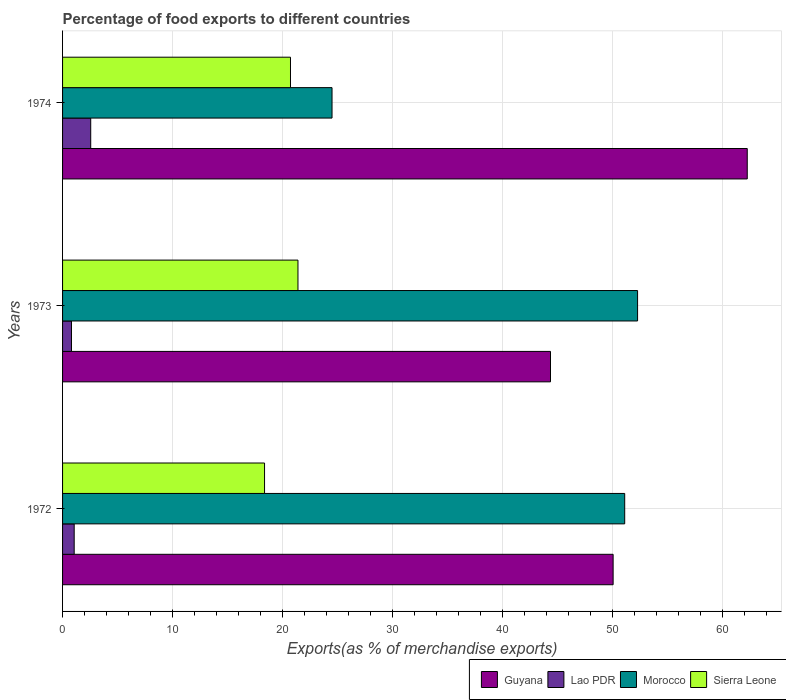How many different coloured bars are there?
Provide a short and direct response. 4. Are the number of bars per tick equal to the number of legend labels?
Provide a short and direct response. Yes. Are the number of bars on each tick of the Y-axis equal?
Provide a succinct answer. Yes. What is the label of the 2nd group of bars from the top?
Provide a short and direct response. 1973. In how many cases, is the number of bars for a given year not equal to the number of legend labels?
Keep it short and to the point. 0. What is the percentage of exports to different countries in Lao PDR in 1973?
Keep it short and to the point. 0.81. Across all years, what is the maximum percentage of exports to different countries in Lao PDR?
Your response must be concise. 2.56. Across all years, what is the minimum percentage of exports to different countries in Lao PDR?
Provide a succinct answer. 0.81. In which year was the percentage of exports to different countries in Lao PDR maximum?
Your answer should be very brief. 1974. In which year was the percentage of exports to different countries in Morocco minimum?
Provide a succinct answer. 1974. What is the total percentage of exports to different countries in Guyana in the graph?
Ensure brevity in your answer.  156.74. What is the difference between the percentage of exports to different countries in Lao PDR in 1973 and that in 1974?
Provide a succinct answer. -1.75. What is the difference between the percentage of exports to different countries in Lao PDR in 1973 and the percentage of exports to different countries in Guyana in 1972?
Keep it short and to the point. -49.27. What is the average percentage of exports to different countries in Guyana per year?
Provide a short and direct response. 52.25. In the year 1972, what is the difference between the percentage of exports to different countries in Sierra Leone and percentage of exports to different countries in Morocco?
Your answer should be very brief. -32.76. What is the ratio of the percentage of exports to different countries in Guyana in 1973 to that in 1974?
Ensure brevity in your answer.  0.71. Is the percentage of exports to different countries in Sierra Leone in 1972 less than that in 1973?
Offer a very short reply. Yes. What is the difference between the highest and the second highest percentage of exports to different countries in Lao PDR?
Your answer should be very brief. 1.5. What is the difference between the highest and the lowest percentage of exports to different countries in Morocco?
Give a very brief answer. 27.79. Is it the case that in every year, the sum of the percentage of exports to different countries in Lao PDR and percentage of exports to different countries in Guyana is greater than the sum of percentage of exports to different countries in Sierra Leone and percentage of exports to different countries in Morocco?
Make the answer very short. No. What does the 2nd bar from the top in 1972 represents?
Provide a short and direct response. Morocco. What does the 1st bar from the bottom in 1974 represents?
Provide a succinct answer. Guyana. Is it the case that in every year, the sum of the percentage of exports to different countries in Guyana and percentage of exports to different countries in Morocco is greater than the percentage of exports to different countries in Sierra Leone?
Your response must be concise. Yes. How many bars are there?
Your response must be concise. 12. Are all the bars in the graph horizontal?
Provide a succinct answer. Yes. Does the graph contain any zero values?
Your answer should be very brief. No. Does the graph contain grids?
Give a very brief answer. Yes. Where does the legend appear in the graph?
Your answer should be very brief. Bottom right. What is the title of the graph?
Your response must be concise. Percentage of food exports to different countries. Does "Slovenia" appear as one of the legend labels in the graph?
Your answer should be very brief. No. What is the label or title of the X-axis?
Your response must be concise. Exports(as % of merchandise exports). What is the Exports(as % of merchandise exports) of Guyana in 1972?
Offer a terse response. 50.08. What is the Exports(as % of merchandise exports) in Lao PDR in 1972?
Offer a very short reply. 1.06. What is the Exports(as % of merchandise exports) in Morocco in 1972?
Your response must be concise. 51.13. What is the Exports(as % of merchandise exports) of Sierra Leone in 1972?
Your answer should be compact. 18.37. What is the Exports(as % of merchandise exports) of Guyana in 1973?
Give a very brief answer. 44.38. What is the Exports(as % of merchandise exports) of Lao PDR in 1973?
Offer a very short reply. 0.81. What is the Exports(as % of merchandise exports) in Morocco in 1973?
Your response must be concise. 52.3. What is the Exports(as % of merchandise exports) of Sierra Leone in 1973?
Offer a very short reply. 21.41. What is the Exports(as % of merchandise exports) of Guyana in 1974?
Make the answer very short. 62.28. What is the Exports(as % of merchandise exports) in Lao PDR in 1974?
Offer a terse response. 2.56. What is the Exports(as % of merchandise exports) in Morocco in 1974?
Offer a very short reply. 24.51. What is the Exports(as % of merchandise exports) in Sierra Leone in 1974?
Your answer should be compact. 20.73. Across all years, what is the maximum Exports(as % of merchandise exports) of Guyana?
Keep it short and to the point. 62.28. Across all years, what is the maximum Exports(as % of merchandise exports) in Lao PDR?
Provide a succinct answer. 2.56. Across all years, what is the maximum Exports(as % of merchandise exports) of Morocco?
Make the answer very short. 52.3. Across all years, what is the maximum Exports(as % of merchandise exports) of Sierra Leone?
Your response must be concise. 21.41. Across all years, what is the minimum Exports(as % of merchandise exports) of Guyana?
Your answer should be compact. 44.38. Across all years, what is the minimum Exports(as % of merchandise exports) of Lao PDR?
Ensure brevity in your answer.  0.81. Across all years, what is the minimum Exports(as % of merchandise exports) in Morocco?
Make the answer very short. 24.51. Across all years, what is the minimum Exports(as % of merchandise exports) of Sierra Leone?
Provide a succinct answer. 18.37. What is the total Exports(as % of merchandise exports) in Guyana in the graph?
Provide a succinct answer. 156.74. What is the total Exports(as % of merchandise exports) of Lao PDR in the graph?
Make the answer very short. 4.43. What is the total Exports(as % of merchandise exports) in Morocco in the graph?
Provide a short and direct response. 127.94. What is the total Exports(as % of merchandise exports) in Sierra Leone in the graph?
Provide a succinct answer. 60.51. What is the difference between the Exports(as % of merchandise exports) in Guyana in 1972 and that in 1973?
Provide a succinct answer. 5.7. What is the difference between the Exports(as % of merchandise exports) in Lao PDR in 1972 and that in 1973?
Provide a succinct answer. 0.25. What is the difference between the Exports(as % of merchandise exports) of Morocco in 1972 and that in 1973?
Offer a terse response. -1.17. What is the difference between the Exports(as % of merchandise exports) of Sierra Leone in 1972 and that in 1973?
Your response must be concise. -3.04. What is the difference between the Exports(as % of merchandise exports) in Guyana in 1972 and that in 1974?
Make the answer very short. -12.2. What is the difference between the Exports(as % of merchandise exports) of Lao PDR in 1972 and that in 1974?
Keep it short and to the point. -1.5. What is the difference between the Exports(as % of merchandise exports) in Morocco in 1972 and that in 1974?
Make the answer very short. 26.62. What is the difference between the Exports(as % of merchandise exports) in Sierra Leone in 1972 and that in 1974?
Ensure brevity in your answer.  -2.36. What is the difference between the Exports(as % of merchandise exports) of Guyana in 1973 and that in 1974?
Make the answer very short. -17.9. What is the difference between the Exports(as % of merchandise exports) of Lao PDR in 1973 and that in 1974?
Give a very brief answer. -1.75. What is the difference between the Exports(as % of merchandise exports) in Morocco in 1973 and that in 1974?
Ensure brevity in your answer.  27.79. What is the difference between the Exports(as % of merchandise exports) of Sierra Leone in 1973 and that in 1974?
Offer a very short reply. 0.68. What is the difference between the Exports(as % of merchandise exports) of Guyana in 1972 and the Exports(as % of merchandise exports) of Lao PDR in 1973?
Provide a succinct answer. 49.27. What is the difference between the Exports(as % of merchandise exports) of Guyana in 1972 and the Exports(as % of merchandise exports) of Morocco in 1973?
Your answer should be compact. -2.22. What is the difference between the Exports(as % of merchandise exports) in Guyana in 1972 and the Exports(as % of merchandise exports) in Sierra Leone in 1973?
Provide a succinct answer. 28.67. What is the difference between the Exports(as % of merchandise exports) of Lao PDR in 1972 and the Exports(as % of merchandise exports) of Morocco in 1973?
Your answer should be compact. -51.24. What is the difference between the Exports(as % of merchandise exports) in Lao PDR in 1972 and the Exports(as % of merchandise exports) in Sierra Leone in 1973?
Your answer should be very brief. -20.35. What is the difference between the Exports(as % of merchandise exports) in Morocco in 1972 and the Exports(as % of merchandise exports) in Sierra Leone in 1973?
Offer a terse response. 29.72. What is the difference between the Exports(as % of merchandise exports) of Guyana in 1972 and the Exports(as % of merchandise exports) of Lao PDR in 1974?
Your response must be concise. 47.52. What is the difference between the Exports(as % of merchandise exports) of Guyana in 1972 and the Exports(as % of merchandise exports) of Morocco in 1974?
Provide a succinct answer. 25.57. What is the difference between the Exports(as % of merchandise exports) in Guyana in 1972 and the Exports(as % of merchandise exports) in Sierra Leone in 1974?
Ensure brevity in your answer.  29.35. What is the difference between the Exports(as % of merchandise exports) of Lao PDR in 1972 and the Exports(as % of merchandise exports) of Morocco in 1974?
Provide a succinct answer. -23.45. What is the difference between the Exports(as % of merchandise exports) of Lao PDR in 1972 and the Exports(as % of merchandise exports) of Sierra Leone in 1974?
Provide a succinct answer. -19.67. What is the difference between the Exports(as % of merchandise exports) in Morocco in 1972 and the Exports(as % of merchandise exports) in Sierra Leone in 1974?
Provide a short and direct response. 30.4. What is the difference between the Exports(as % of merchandise exports) in Guyana in 1973 and the Exports(as % of merchandise exports) in Lao PDR in 1974?
Ensure brevity in your answer.  41.82. What is the difference between the Exports(as % of merchandise exports) of Guyana in 1973 and the Exports(as % of merchandise exports) of Morocco in 1974?
Your answer should be compact. 19.87. What is the difference between the Exports(as % of merchandise exports) in Guyana in 1973 and the Exports(as % of merchandise exports) in Sierra Leone in 1974?
Ensure brevity in your answer.  23.65. What is the difference between the Exports(as % of merchandise exports) of Lao PDR in 1973 and the Exports(as % of merchandise exports) of Morocco in 1974?
Your answer should be compact. -23.7. What is the difference between the Exports(as % of merchandise exports) of Lao PDR in 1973 and the Exports(as % of merchandise exports) of Sierra Leone in 1974?
Offer a terse response. -19.92. What is the difference between the Exports(as % of merchandise exports) of Morocco in 1973 and the Exports(as % of merchandise exports) of Sierra Leone in 1974?
Offer a very short reply. 31.57. What is the average Exports(as % of merchandise exports) of Guyana per year?
Your answer should be very brief. 52.25. What is the average Exports(as % of merchandise exports) in Lao PDR per year?
Provide a succinct answer. 1.48. What is the average Exports(as % of merchandise exports) in Morocco per year?
Provide a succinct answer. 42.65. What is the average Exports(as % of merchandise exports) of Sierra Leone per year?
Keep it short and to the point. 20.17. In the year 1972, what is the difference between the Exports(as % of merchandise exports) in Guyana and Exports(as % of merchandise exports) in Lao PDR?
Make the answer very short. 49.02. In the year 1972, what is the difference between the Exports(as % of merchandise exports) in Guyana and Exports(as % of merchandise exports) in Morocco?
Offer a very short reply. -1.05. In the year 1972, what is the difference between the Exports(as % of merchandise exports) in Guyana and Exports(as % of merchandise exports) in Sierra Leone?
Give a very brief answer. 31.71. In the year 1972, what is the difference between the Exports(as % of merchandise exports) in Lao PDR and Exports(as % of merchandise exports) in Morocco?
Ensure brevity in your answer.  -50.07. In the year 1972, what is the difference between the Exports(as % of merchandise exports) in Lao PDR and Exports(as % of merchandise exports) in Sierra Leone?
Offer a terse response. -17.31. In the year 1972, what is the difference between the Exports(as % of merchandise exports) in Morocco and Exports(as % of merchandise exports) in Sierra Leone?
Your answer should be very brief. 32.76. In the year 1973, what is the difference between the Exports(as % of merchandise exports) in Guyana and Exports(as % of merchandise exports) in Lao PDR?
Offer a terse response. 43.57. In the year 1973, what is the difference between the Exports(as % of merchandise exports) of Guyana and Exports(as % of merchandise exports) of Morocco?
Make the answer very short. -7.92. In the year 1973, what is the difference between the Exports(as % of merchandise exports) of Guyana and Exports(as % of merchandise exports) of Sierra Leone?
Ensure brevity in your answer.  22.97. In the year 1973, what is the difference between the Exports(as % of merchandise exports) in Lao PDR and Exports(as % of merchandise exports) in Morocco?
Keep it short and to the point. -51.49. In the year 1973, what is the difference between the Exports(as % of merchandise exports) in Lao PDR and Exports(as % of merchandise exports) in Sierra Leone?
Make the answer very short. -20.6. In the year 1973, what is the difference between the Exports(as % of merchandise exports) of Morocco and Exports(as % of merchandise exports) of Sierra Leone?
Your response must be concise. 30.89. In the year 1974, what is the difference between the Exports(as % of merchandise exports) in Guyana and Exports(as % of merchandise exports) in Lao PDR?
Provide a short and direct response. 59.72. In the year 1974, what is the difference between the Exports(as % of merchandise exports) of Guyana and Exports(as % of merchandise exports) of Morocco?
Make the answer very short. 37.77. In the year 1974, what is the difference between the Exports(as % of merchandise exports) of Guyana and Exports(as % of merchandise exports) of Sierra Leone?
Ensure brevity in your answer.  41.55. In the year 1974, what is the difference between the Exports(as % of merchandise exports) in Lao PDR and Exports(as % of merchandise exports) in Morocco?
Keep it short and to the point. -21.95. In the year 1974, what is the difference between the Exports(as % of merchandise exports) of Lao PDR and Exports(as % of merchandise exports) of Sierra Leone?
Offer a very short reply. -18.17. In the year 1974, what is the difference between the Exports(as % of merchandise exports) of Morocco and Exports(as % of merchandise exports) of Sierra Leone?
Provide a short and direct response. 3.78. What is the ratio of the Exports(as % of merchandise exports) of Guyana in 1972 to that in 1973?
Offer a very short reply. 1.13. What is the ratio of the Exports(as % of merchandise exports) in Lao PDR in 1972 to that in 1973?
Offer a terse response. 1.3. What is the ratio of the Exports(as % of merchandise exports) in Morocco in 1972 to that in 1973?
Provide a short and direct response. 0.98. What is the ratio of the Exports(as % of merchandise exports) in Sierra Leone in 1972 to that in 1973?
Keep it short and to the point. 0.86. What is the ratio of the Exports(as % of merchandise exports) in Guyana in 1972 to that in 1974?
Your answer should be compact. 0.8. What is the ratio of the Exports(as % of merchandise exports) in Lao PDR in 1972 to that in 1974?
Make the answer very short. 0.41. What is the ratio of the Exports(as % of merchandise exports) in Morocco in 1972 to that in 1974?
Keep it short and to the point. 2.09. What is the ratio of the Exports(as % of merchandise exports) in Sierra Leone in 1972 to that in 1974?
Your answer should be very brief. 0.89. What is the ratio of the Exports(as % of merchandise exports) of Guyana in 1973 to that in 1974?
Your answer should be compact. 0.71. What is the ratio of the Exports(as % of merchandise exports) of Lao PDR in 1973 to that in 1974?
Keep it short and to the point. 0.32. What is the ratio of the Exports(as % of merchandise exports) of Morocco in 1973 to that in 1974?
Your answer should be compact. 2.13. What is the ratio of the Exports(as % of merchandise exports) in Sierra Leone in 1973 to that in 1974?
Provide a short and direct response. 1.03. What is the difference between the highest and the second highest Exports(as % of merchandise exports) of Guyana?
Your answer should be very brief. 12.2. What is the difference between the highest and the second highest Exports(as % of merchandise exports) in Lao PDR?
Your answer should be very brief. 1.5. What is the difference between the highest and the second highest Exports(as % of merchandise exports) of Morocco?
Offer a very short reply. 1.17. What is the difference between the highest and the second highest Exports(as % of merchandise exports) in Sierra Leone?
Your response must be concise. 0.68. What is the difference between the highest and the lowest Exports(as % of merchandise exports) in Guyana?
Keep it short and to the point. 17.9. What is the difference between the highest and the lowest Exports(as % of merchandise exports) in Lao PDR?
Keep it short and to the point. 1.75. What is the difference between the highest and the lowest Exports(as % of merchandise exports) of Morocco?
Your answer should be very brief. 27.79. What is the difference between the highest and the lowest Exports(as % of merchandise exports) of Sierra Leone?
Give a very brief answer. 3.04. 